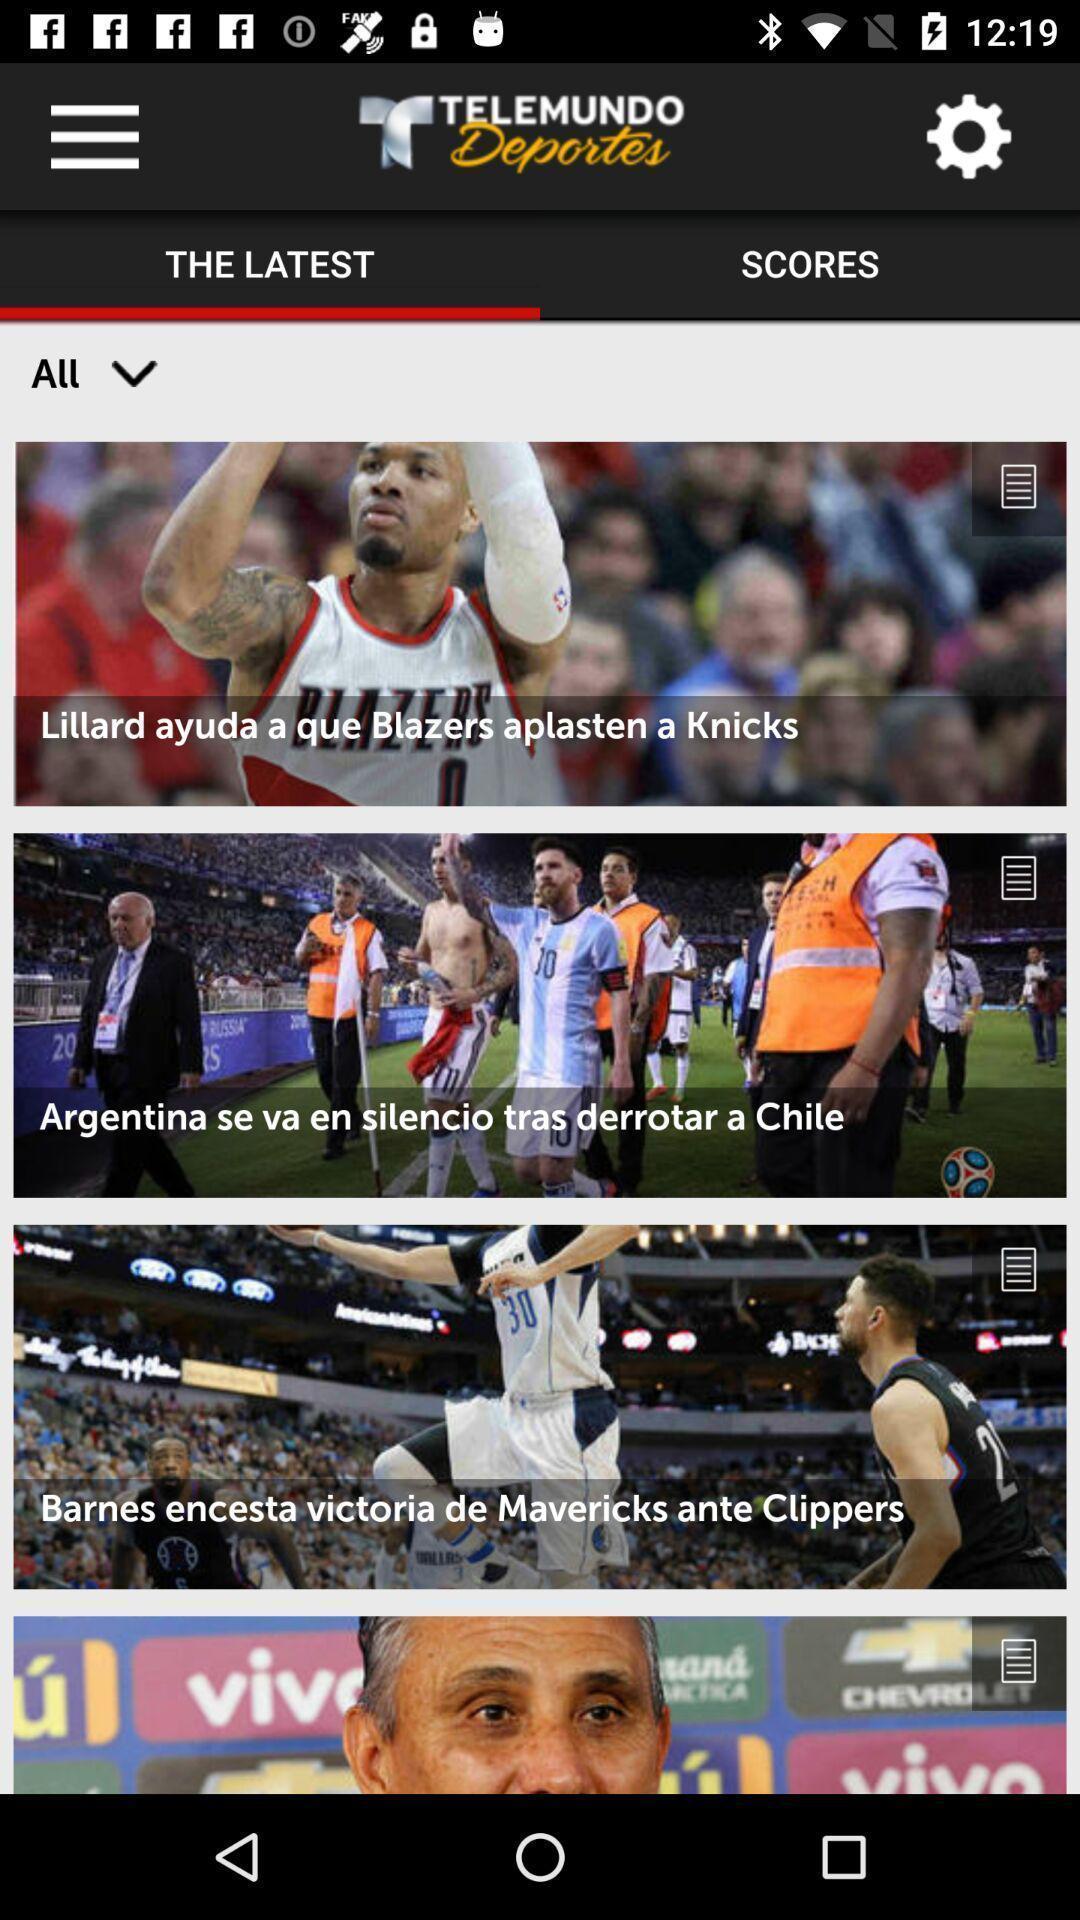Describe this image in words. Screen shows multiple articles in a sports app. 